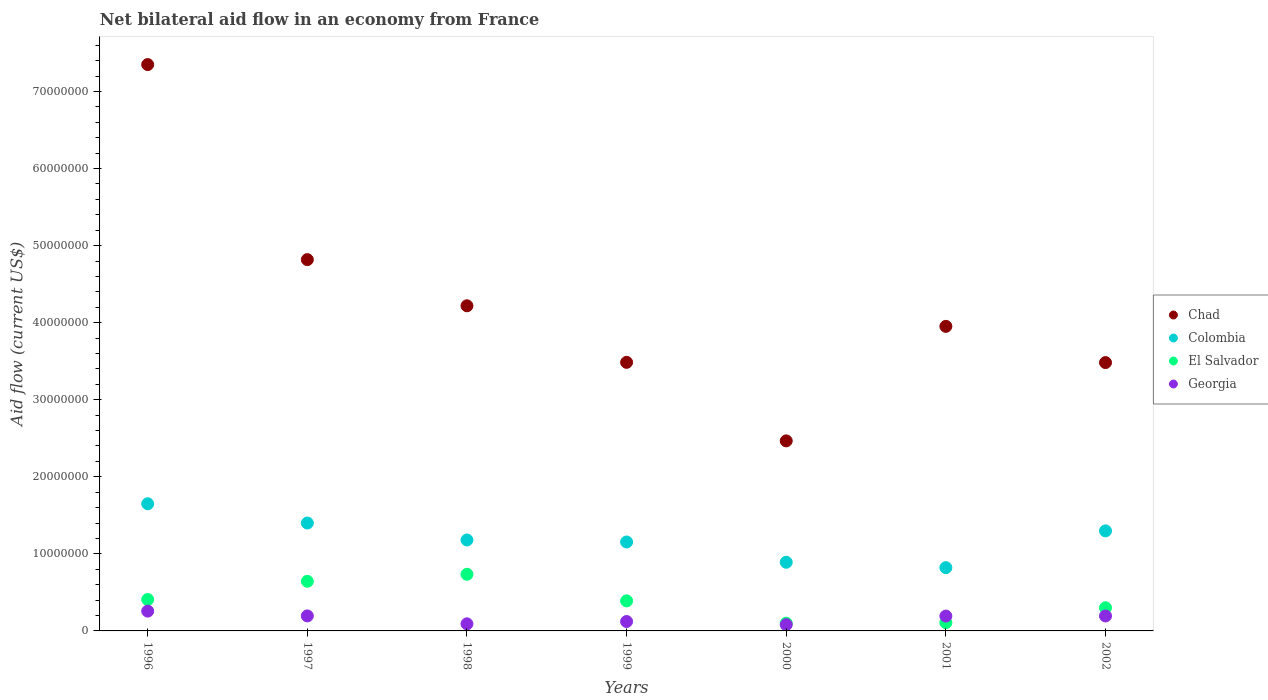How many different coloured dotlines are there?
Your answer should be compact. 4. What is the net bilateral aid flow in El Salvador in 1997?
Provide a succinct answer. 6.44e+06. Across all years, what is the maximum net bilateral aid flow in Georgia?
Your response must be concise. 2.57e+06. Across all years, what is the minimum net bilateral aid flow in El Salvador?
Your answer should be very brief. 1.00e+06. In which year was the net bilateral aid flow in El Salvador maximum?
Your answer should be very brief. 1998. What is the total net bilateral aid flow in El Salvador in the graph?
Offer a very short reply. 2.68e+07. What is the difference between the net bilateral aid flow in El Salvador in 1996 and that in 2002?
Give a very brief answer. 1.07e+06. What is the difference between the net bilateral aid flow in Chad in 1997 and the net bilateral aid flow in Colombia in 2001?
Provide a succinct answer. 4.00e+07. What is the average net bilateral aid flow in Colombia per year?
Provide a succinct answer. 1.20e+07. In the year 2001, what is the difference between the net bilateral aid flow in Chad and net bilateral aid flow in Georgia?
Your answer should be very brief. 3.76e+07. What is the ratio of the net bilateral aid flow in Colombia in 1999 to that in 2000?
Make the answer very short. 1.3. Is the net bilateral aid flow in Chad in 1997 less than that in 2001?
Ensure brevity in your answer.  No. What is the difference between the highest and the second highest net bilateral aid flow in Chad?
Ensure brevity in your answer.  2.53e+07. What is the difference between the highest and the lowest net bilateral aid flow in Colombia?
Offer a very short reply. 8.29e+06. Is the sum of the net bilateral aid flow in El Salvador in 1998 and 1999 greater than the maximum net bilateral aid flow in Chad across all years?
Ensure brevity in your answer.  No. Is it the case that in every year, the sum of the net bilateral aid flow in Chad and net bilateral aid flow in El Salvador  is greater than the sum of net bilateral aid flow in Colombia and net bilateral aid flow in Georgia?
Make the answer very short. Yes. Does the net bilateral aid flow in Georgia monotonically increase over the years?
Keep it short and to the point. No. Is the net bilateral aid flow in Georgia strictly less than the net bilateral aid flow in Chad over the years?
Offer a very short reply. Yes. How many years are there in the graph?
Provide a short and direct response. 7. Does the graph contain any zero values?
Give a very brief answer. No. Does the graph contain grids?
Offer a terse response. No. Where does the legend appear in the graph?
Your response must be concise. Center right. What is the title of the graph?
Make the answer very short. Net bilateral aid flow in an economy from France. What is the label or title of the X-axis?
Make the answer very short. Years. What is the Aid flow (current US$) of Chad in 1996?
Provide a short and direct response. 7.35e+07. What is the Aid flow (current US$) of Colombia in 1996?
Your answer should be compact. 1.65e+07. What is the Aid flow (current US$) in El Salvador in 1996?
Keep it short and to the point. 4.08e+06. What is the Aid flow (current US$) in Georgia in 1996?
Your response must be concise. 2.57e+06. What is the Aid flow (current US$) in Chad in 1997?
Your response must be concise. 4.82e+07. What is the Aid flow (current US$) of Colombia in 1997?
Keep it short and to the point. 1.40e+07. What is the Aid flow (current US$) of El Salvador in 1997?
Give a very brief answer. 6.44e+06. What is the Aid flow (current US$) of Georgia in 1997?
Give a very brief answer. 1.95e+06. What is the Aid flow (current US$) of Chad in 1998?
Your answer should be compact. 4.22e+07. What is the Aid flow (current US$) in Colombia in 1998?
Provide a succinct answer. 1.18e+07. What is the Aid flow (current US$) of El Salvador in 1998?
Offer a very short reply. 7.35e+06. What is the Aid flow (current US$) in Georgia in 1998?
Offer a terse response. 9.20e+05. What is the Aid flow (current US$) in Chad in 1999?
Your response must be concise. 3.48e+07. What is the Aid flow (current US$) in Colombia in 1999?
Your response must be concise. 1.15e+07. What is the Aid flow (current US$) of El Salvador in 1999?
Your answer should be very brief. 3.90e+06. What is the Aid flow (current US$) in Georgia in 1999?
Ensure brevity in your answer.  1.22e+06. What is the Aid flow (current US$) of Chad in 2000?
Make the answer very short. 2.47e+07. What is the Aid flow (current US$) in Colombia in 2000?
Offer a terse response. 8.91e+06. What is the Aid flow (current US$) in Georgia in 2000?
Your answer should be very brief. 8.10e+05. What is the Aid flow (current US$) in Chad in 2001?
Your response must be concise. 3.95e+07. What is the Aid flow (current US$) of Colombia in 2001?
Provide a succinct answer. 8.21e+06. What is the Aid flow (current US$) in El Salvador in 2001?
Provide a succinct answer. 1.07e+06. What is the Aid flow (current US$) in Georgia in 2001?
Provide a short and direct response. 1.93e+06. What is the Aid flow (current US$) in Chad in 2002?
Your answer should be very brief. 3.48e+07. What is the Aid flow (current US$) in Colombia in 2002?
Provide a succinct answer. 1.30e+07. What is the Aid flow (current US$) of El Salvador in 2002?
Your answer should be compact. 3.01e+06. What is the Aid flow (current US$) in Georgia in 2002?
Give a very brief answer. 1.94e+06. Across all years, what is the maximum Aid flow (current US$) in Chad?
Your response must be concise. 7.35e+07. Across all years, what is the maximum Aid flow (current US$) of Colombia?
Make the answer very short. 1.65e+07. Across all years, what is the maximum Aid flow (current US$) in El Salvador?
Ensure brevity in your answer.  7.35e+06. Across all years, what is the maximum Aid flow (current US$) of Georgia?
Make the answer very short. 2.57e+06. Across all years, what is the minimum Aid flow (current US$) of Chad?
Ensure brevity in your answer.  2.47e+07. Across all years, what is the minimum Aid flow (current US$) in Colombia?
Your answer should be very brief. 8.21e+06. Across all years, what is the minimum Aid flow (current US$) in El Salvador?
Your answer should be very brief. 1.00e+06. Across all years, what is the minimum Aid flow (current US$) in Georgia?
Make the answer very short. 8.10e+05. What is the total Aid flow (current US$) in Chad in the graph?
Your response must be concise. 2.98e+08. What is the total Aid flow (current US$) in Colombia in the graph?
Provide a succinct answer. 8.39e+07. What is the total Aid flow (current US$) of El Salvador in the graph?
Keep it short and to the point. 2.68e+07. What is the total Aid flow (current US$) of Georgia in the graph?
Make the answer very short. 1.13e+07. What is the difference between the Aid flow (current US$) in Chad in 1996 and that in 1997?
Make the answer very short. 2.53e+07. What is the difference between the Aid flow (current US$) in Colombia in 1996 and that in 1997?
Give a very brief answer. 2.50e+06. What is the difference between the Aid flow (current US$) in El Salvador in 1996 and that in 1997?
Your answer should be very brief. -2.36e+06. What is the difference between the Aid flow (current US$) in Georgia in 1996 and that in 1997?
Ensure brevity in your answer.  6.20e+05. What is the difference between the Aid flow (current US$) in Chad in 1996 and that in 1998?
Provide a succinct answer. 3.13e+07. What is the difference between the Aid flow (current US$) in Colombia in 1996 and that in 1998?
Offer a terse response. 4.70e+06. What is the difference between the Aid flow (current US$) of El Salvador in 1996 and that in 1998?
Your answer should be very brief. -3.27e+06. What is the difference between the Aid flow (current US$) of Georgia in 1996 and that in 1998?
Your answer should be compact. 1.65e+06. What is the difference between the Aid flow (current US$) of Chad in 1996 and that in 1999?
Make the answer very short. 3.86e+07. What is the difference between the Aid flow (current US$) of Colombia in 1996 and that in 1999?
Ensure brevity in your answer.  4.96e+06. What is the difference between the Aid flow (current US$) of El Salvador in 1996 and that in 1999?
Ensure brevity in your answer.  1.80e+05. What is the difference between the Aid flow (current US$) of Georgia in 1996 and that in 1999?
Your answer should be very brief. 1.35e+06. What is the difference between the Aid flow (current US$) in Chad in 1996 and that in 2000?
Make the answer very short. 4.88e+07. What is the difference between the Aid flow (current US$) in Colombia in 1996 and that in 2000?
Provide a succinct answer. 7.59e+06. What is the difference between the Aid flow (current US$) in El Salvador in 1996 and that in 2000?
Offer a very short reply. 3.08e+06. What is the difference between the Aid flow (current US$) in Georgia in 1996 and that in 2000?
Keep it short and to the point. 1.76e+06. What is the difference between the Aid flow (current US$) in Chad in 1996 and that in 2001?
Your answer should be compact. 3.40e+07. What is the difference between the Aid flow (current US$) of Colombia in 1996 and that in 2001?
Make the answer very short. 8.29e+06. What is the difference between the Aid flow (current US$) of El Salvador in 1996 and that in 2001?
Provide a short and direct response. 3.01e+06. What is the difference between the Aid flow (current US$) in Georgia in 1996 and that in 2001?
Give a very brief answer. 6.40e+05. What is the difference between the Aid flow (current US$) in Chad in 1996 and that in 2002?
Offer a very short reply. 3.87e+07. What is the difference between the Aid flow (current US$) in Colombia in 1996 and that in 2002?
Your answer should be compact. 3.52e+06. What is the difference between the Aid flow (current US$) of El Salvador in 1996 and that in 2002?
Your response must be concise. 1.07e+06. What is the difference between the Aid flow (current US$) in Georgia in 1996 and that in 2002?
Offer a terse response. 6.30e+05. What is the difference between the Aid flow (current US$) of Chad in 1997 and that in 1998?
Keep it short and to the point. 5.99e+06. What is the difference between the Aid flow (current US$) in Colombia in 1997 and that in 1998?
Give a very brief answer. 2.20e+06. What is the difference between the Aid flow (current US$) in El Salvador in 1997 and that in 1998?
Give a very brief answer. -9.10e+05. What is the difference between the Aid flow (current US$) of Georgia in 1997 and that in 1998?
Offer a terse response. 1.03e+06. What is the difference between the Aid flow (current US$) in Chad in 1997 and that in 1999?
Keep it short and to the point. 1.33e+07. What is the difference between the Aid flow (current US$) of Colombia in 1997 and that in 1999?
Ensure brevity in your answer.  2.46e+06. What is the difference between the Aid flow (current US$) of El Salvador in 1997 and that in 1999?
Your response must be concise. 2.54e+06. What is the difference between the Aid flow (current US$) of Georgia in 1997 and that in 1999?
Ensure brevity in your answer.  7.30e+05. What is the difference between the Aid flow (current US$) in Chad in 1997 and that in 2000?
Your answer should be compact. 2.35e+07. What is the difference between the Aid flow (current US$) in Colombia in 1997 and that in 2000?
Keep it short and to the point. 5.09e+06. What is the difference between the Aid flow (current US$) in El Salvador in 1997 and that in 2000?
Give a very brief answer. 5.44e+06. What is the difference between the Aid flow (current US$) in Georgia in 1997 and that in 2000?
Your response must be concise. 1.14e+06. What is the difference between the Aid flow (current US$) in Chad in 1997 and that in 2001?
Provide a succinct answer. 8.66e+06. What is the difference between the Aid flow (current US$) of Colombia in 1997 and that in 2001?
Give a very brief answer. 5.79e+06. What is the difference between the Aid flow (current US$) in El Salvador in 1997 and that in 2001?
Ensure brevity in your answer.  5.37e+06. What is the difference between the Aid flow (current US$) of Chad in 1997 and that in 2002?
Keep it short and to the point. 1.34e+07. What is the difference between the Aid flow (current US$) in Colombia in 1997 and that in 2002?
Keep it short and to the point. 1.02e+06. What is the difference between the Aid flow (current US$) of El Salvador in 1997 and that in 2002?
Offer a very short reply. 3.43e+06. What is the difference between the Aid flow (current US$) in Georgia in 1997 and that in 2002?
Give a very brief answer. 10000. What is the difference between the Aid flow (current US$) of Chad in 1998 and that in 1999?
Your answer should be very brief. 7.34e+06. What is the difference between the Aid flow (current US$) of Colombia in 1998 and that in 1999?
Your answer should be compact. 2.60e+05. What is the difference between the Aid flow (current US$) in El Salvador in 1998 and that in 1999?
Your answer should be compact. 3.45e+06. What is the difference between the Aid flow (current US$) in Georgia in 1998 and that in 1999?
Make the answer very short. -3.00e+05. What is the difference between the Aid flow (current US$) in Chad in 1998 and that in 2000?
Your answer should be compact. 1.75e+07. What is the difference between the Aid flow (current US$) in Colombia in 1998 and that in 2000?
Give a very brief answer. 2.89e+06. What is the difference between the Aid flow (current US$) of El Salvador in 1998 and that in 2000?
Make the answer very short. 6.35e+06. What is the difference between the Aid flow (current US$) in Georgia in 1998 and that in 2000?
Give a very brief answer. 1.10e+05. What is the difference between the Aid flow (current US$) in Chad in 1998 and that in 2001?
Provide a succinct answer. 2.67e+06. What is the difference between the Aid flow (current US$) in Colombia in 1998 and that in 2001?
Your answer should be compact. 3.59e+06. What is the difference between the Aid flow (current US$) of El Salvador in 1998 and that in 2001?
Ensure brevity in your answer.  6.28e+06. What is the difference between the Aid flow (current US$) of Georgia in 1998 and that in 2001?
Offer a very short reply. -1.01e+06. What is the difference between the Aid flow (current US$) in Chad in 1998 and that in 2002?
Your response must be concise. 7.37e+06. What is the difference between the Aid flow (current US$) of Colombia in 1998 and that in 2002?
Give a very brief answer. -1.18e+06. What is the difference between the Aid flow (current US$) of El Salvador in 1998 and that in 2002?
Provide a succinct answer. 4.34e+06. What is the difference between the Aid flow (current US$) of Georgia in 1998 and that in 2002?
Keep it short and to the point. -1.02e+06. What is the difference between the Aid flow (current US$) of Chad in 1999 and that in 2000?
Your answer should be very brief. 1.02e+07. What is the difference between the Aid flow (current US$) of Colombia in 1999 and that in 2000?
Give a very brief answer. 2.63e+06. What is the difference between the Aid flow (current US$) of El Salvador in 1999 and that in 2000?
Offer a very short reply. 2.90e+06. What is the difference between the Aid flow (current US$) of Chad in 1999 and that in 2001?
Provide a succinct answer. -4.67e+06. What is the difference between the Aid flow (current US$) in Colombia in 1999 and that in 2001?
Give a very brief answer. 3.33e+06. What is the difference between the Aid flow (current US$) of El Salvador in 1999 and that in 2001?
Ensure brevity in your answer.  2.83e+06. What is the difference between the Aid flow (current US$) of Georgia in 1999 and that in 2001?
Keep it short and to the point. -7.10e+05. What is the difference between the Aid flow (current US$) in Colombia in 1999 and that in 2002?
Offer a terse response. -1.44e+06. What is the difference between the Aid flow (current US$) in El Salvador in 1999 and that in 2002?
Ensure brevity in your answer.  8.90e+05. What is the difference between the Aid flow (current US$) in Georgia in 1999 and that in 2002?
Your answer should be compact. -7.20e+05. What is the difference between the Aid flow (current US$) of Chad in 2000 and that in 2001?
Ensure brevity in your answer.  -1.49e+07. What is the difference between the Aid flow (current US$) of El Salvador in 2000 and that in 2001?
Your response must be concise. -7.00e+04. What is the difference between the Aid flow (current US$) of Georgia in 2000 and that in 2001?
Provide a succinct answer. -1.12e+06. What is the difference between the Aid flow (current US$) of Chad in 2000 and that in 2002?
Give a very brief answer. -1.02e+07. What is the difference between the Aid flow (current US$) of Colombia in 2000 and that in 2002?
Offer a very short reply. -4.07e+06. What is the difference between the Aid flow (current US$) in El Salvador in 2000 and that in 2002?
Keep it short and to the point. -2.01e+06. What is the difference between the Aid flow (current US$) in Georgia in 2000 and that in 2002?
Give a very brief answer. -1.13e+06. What is the difference between the Aid flow (current US$) of Chad in 2001 and that in 2002?
Offer a terse response. 4.70e+06. What is the difference between the Aid flow (current US$) of Colombia in 2001 and that in 2002?
Your answer should be very brief. -4.77e+06. What is the difference between the Aid flow (current US$) of El Salvador in 2001 and that in 2002?
Your answer should be compact. -1.94e+06. What is the difference between the Aid flow (current US$) of Chad in 1996 and the Aid flow (current US$) of Colombia in 1997?
Provide a short and direct response. 5.95e+07. What is the difference between the Aid flow (current US$) of Chad in 1996 and the Aid flow (current US$) of El Salvador in 1997?
Offer a very short reply. 6.70e+07. What is the difference between the Aid flow (current US$) of Chad in 1996 and the Aid flow (current US$) of Georgia in 1997?
Give a very brief answer. 7.15e+07. What is the difference between the Aid flow (current US$) in Colombia in 1996 and the Aid flow (current US$) in El Salvador in 1997?
Provide a short and direct response. 1.01e+07. What is the difference between the Aid flow (current US$) in Colombia in 1996 and the Aid flow (current US$) in Georgia in 1997?
Offer a very short reply. 1.46e+07. What is the difference between the Aid flow (current US$) in El Salvador in 1996 and the Aid flow (current US$) in Georgia in 1997?
Your response must be concise. 2.13e+06. What is the difference between the Aid flow (current US$) of Chad in 1996 and the Aid flow (current US$) of Colombia in 1998?
Your answer should be compact. 6.17e+07. What is the difference between the Aid flow (current US$) in Chad in 1996 and the Aid flow (current US$) in El Salvador in 1998?
Your response must be concise. 6.61e+07. What is the difference between the Aid flow (current US$) in Chad in 1996 and the Aid flow (current US$) in Georgia in 1998?
Offer a very short reply. 7.26e+07. What is the difference between the Aid flow (current US$) of Colombia in 1996 and the Aid flow (current US$) of El Salvador in 1998?
Keep it short and to the point. 9.15e+06. What is the difference between the Aid flow (current US$) in Colombia in 1996 and the Aid flow (current US$) in Georgia in 1998?
Ensure brevity in your answer.  1.56e+07. What is the difference between the Aid flow (current US$) of El Salvador in 1996 and the Aid flow (current US$) of Georgia in 1998?
Offer a terse response. 3.16e+06. What is the difference between the Aid flow (current US$) of Chad in 1996 and the Aid flow (current US$) of Colombia in 1999?
Ensure brevity in your answer.  6.20e+07. What is the difference between the Aid flow (current US$) in Chad in 1996 and the Aid flow (current US$) in El Salvador in 1999?
Offer a very short reply. 6.96e+07. What is the difference between the Aid flow (current US$) in Chad in 1996 and the Aid flow (current US$) in Georgia in 1999?
Your answer should be compact. 7.23e+07. What is the difference between the Aid flow (current US$) in Colombia in 1996 and the Aid flow (current US$) in El Salvador in 1999?
Give a very brief answer. 1.26e+07. What is the difference between the Aid flow (current US$) of Colombia in 1996 and the Aid flow (current US$) of Georgia in 1999?
Give a very brief answer. 1.53e+07. What is the difference between the Aid flow (current US$) of El Salvador in 1996 and the Aid flow (current US$) of Georgia in 1999?
Your answer should be very brief. 2.86e+06. What is the difference between the Aid flow (current US$) of Chad in 1996 and the Aid flow (current US$) of Colombia in 2000?
Your response must be concise. 6.46e+07. What is the difference between the Aid flow (current US$) in Chad in 1996 and the Aid flow (current US$) in El Salvador in 2000?
Ensure brevity in your answer.  7.25e+07. What is the difference between the Aid flow (current US$) in Chad in 1996 and the Aid flow (current US$) in Georgia in 2000?
Your response must be concise. 7.27e+07. What is the difference between the Aid flow (current US$) of Colombia in 1996 and the Aid flow (current US$) of El Salvador in 2000?
Your answer should be very brief. 1.55e+07. What is the difference between the Aid flow (current US$) of Colombia in 1996 and the Aid flow (current US$) of Georgia in 2000?
Keep it short and to the point. 1.57e+07. What is the difference between the Aid flow (current US$) in El Salvador in 1996 and the Aid flow (current US$) in Georgia in 2000?
Your response must be concise. 3.27e+06. What is the difference between the Aid flow (current US$) of Chad in 1996 and the Aid flow (current US$) of Colombia in 2001?
Your answer should be very brief. 6.53e+07. What is the difference between the Aid flow (current US$) in Chad in 1996 and the Aid flow (current US$) in El Salvador in 2001?
Make the answer very short. 7.24e+07. What is the difference between the Aid flow (current US$) of Chad in 1996 and the Aid flow (current US$) of Georgia in 2001?
Keep it short and to the point. 7.16e+07. What is the difference between the Aid flow (current US$) of Colombia in 1996 and the Aid flow (current US$) of El Salvador in 2001?
Your response must be concise. 1.54e+07. What is the difference between the Aid flow (current US$) of Colombia in 1996 and the Aid flow (current US$) of Georgia in 2001?
Your response must be concise. 1.46e+07. What is the difference between the Aid flow (current US$) of El Salvador in 1996 and the Aid flow (current US$) of Georgia in 2001?
Keep it short and to the point. 2.15e+06. What is the difference between the Aid flow (current US$) in Chad in 1996 and the Aid flow (current US$) in Colombia in 2002?
Your answer should be compact. 6.05e+07. What is the difference between the Aid flow (current US$) in Chad in 1996 and the Aid flow (current US$) in El Salvador in 2002?
Give a very brief answer. 7.05e+07. What is the difference between the Aid flow (current US$) of Chad in 1996 and the Aid flow (current US$) of Georgia in 2002?
Give a very brief answer. 7.16e+07. What is the difference between the Aid flow (current US$) in Colombia in 1996 and the Aid flow (current US$) in El Salvador in 2002?
Keep it short and to the point. 1.35e+07. What is the difference between the Aid flow (current US$) of Colombia in 1996 and the Aid flow (current US$) of Georgia in 2002?
Your answer should be very brief. 1.46e+07. What is the difference between the Aid flow (current US$) in El Salvador in 1996 and the Aid flow (current US$) in Georgia in 2002?
Provide a succinct answer. 2.14e+06. What is the difference between the Aid flow (current US$) of Chad in 1997 and the Aid flow (current US$) of Colombia in 1998?
Your response must be concise. 3.64e+07. What is the difference between the Aid flow (current US$) in Chad in 1997 and the Aid flow (current US$) in El Salvador in 1998?
Your response must be concise. 4.08e+07. What is the difference between the Aid flow (current US$) in Chad in 1997 and the Aid flow (current US$) in Georgia in 1998?
Your answer should be very brief. 4.73e+07. What is the difference between the Aid flow (current US$) of Colombia in 1997 and the Aid flow (current US$) of El Salvador in 1998?
Your response must be concise. 6.65e+06. What is the difference between the Aid flow (current US$) in Colombia in 1997 and the Aid flow (current US$) in Georgia in 1998?
Your response must be concise. 1.31e+07. What is the difference between the Aid flow (current US$) in El Salvador in 1997 and the Aid flow (current US$) in Georgia in 1998?
Your answer should be compact. 5.52e+06. What is the difference between the Aid flow (current US$) of Chad in 1997 and the Aid flow (current US$) of Colombia in 1999?
Give a very brief answer. 3.66e+07. What is the difference between the Aid flow (current US$) in Chad in 1997 and the Aid flow (current US$) in El Salvador in 1999?
Provide a succinct answer. 4.43e+07. What is the difference between the Aid flow (current US$) in Chad in 1997 and the Aid flow (current US$) in Georgia in 1999?
Provide a short and direct response. 4.70e+07. What is the difference between the Aid flow (current US$) in Colombia in 1997 and the Aid flow (current US$) in El Salvador in 1999?
Provide a succinct answer. 1.01e+07. What is the difference between the Aid flow (current US$) in Colombia in 1997 and the Aid flow (current US$) in Georgia in 1999?
Provide a short and direct response. 1.28e+07. What is the difference between the Aid flow (current US$) in El Salvador in 1997 and the Aid flow (current US$) in Georgia in 1999?
Ensure brevity in your answer.  5.22e+06. What is the difference between the Aid flow (current US$) of Chad in 1997 and the Aid flow (current US$) of Colombia in 2000?
Offer a terse response. 3.93e+07. What is the difference between the Aid flow (current US$) in Chad in 1997 and the Aid flow (current US$) in El Salvador in 2000?
Your response must be concise. 4.72e+07. What is the difference between the Aid flow (current US$) in Chad in 1997 and the Aid flow (current US$) in Georgia in 2000?
Your answer should be compact. 4.74e+07. What is the difference between the Aid flow (current US$) of Colombia in 1997 and the Aid flow (current US$) of El Salvador in 2000?
Keep it short and to the point. 1.30e+07. What is the difference between the Aid flow (current US$) in Colombia in 1997 and the Aid flow (current US$) in Georgia in 2000?
Offer a terse response. 1.32e+07. What is the difference between the Aid flow (current US$) of El Salvador in 1997 and the Aid flow (current US$) of Georgia in 2000?
Give a very brief answer. 5.63e+06. What is the difference between the Aid flow (current US$) of Chad in 1997 and the Aid flow (current US$) of Colombia in 2001?
Your answer should be very brief. 4.00e+07. What is the difference between the Aid flow (current US$) in Chad in 1997 and the Aid flow (current US$) in El Salvador in 2001?
Offer a very short reply. 4.71e+07. What is the difference between the Aid flow (current US$) of Chad in 1997 and the Aid flow (current US$) of Georgia in 2001?
Offer a terse response. 4.62e+07. What is the difference between the Aid flow (current US$) in Colombia in 1997 and the Aid flow (current US$) in El Salvador in 2001?
Your response must be concise. 1.29e+07. What is the difference between the Aid flow (current US$) of Colombia in 1997 and the Aid flow (current US$) of Georgia in 2001?
Provide a short and direct response. 1.21e+07. What is the difference between the Aid flow (current US$) of El Salvador in 1997 and the Aid flow (current US$) of Georgia in 2001?
Ensure brevity in your answer.  4.51e+06. What is the difference between the Aid flow (current US$) of Chad in 1997 and the Aid flow (current US$) of Colombia in 2002?
Offer a terse response. 3.52e+07. What is the difference between the Aid flow (current US$) in Chad in 1997 and the Aid flow (current US$) in El Salvador in 2002?
Make the answer very short. 4.52e+07. What is the difference between the Aid flow (current US$) in Chad in 1997 and the Aid flow (current US$) in Georgia in 2002?
Keep it short and to the point. 4.62e+07. What is the difference between the Aid flow (current US$) of Colombia in 1997 and the Aid flow (current US$) of El Salvador in 2002?
Your answer should be very brief. 1.10e+07. What is the difference between the Aid flow (current US$) in Colombia in 1997 and the Aid flow (current US$) in Georgia in 2002?
Offer a very short reply. 1.21e+07. What is the difference between the Aid flow (current US$) of El Salvador in 1997 and the Aid flow (current US$) of Georgia in 2002?
Ensure brevity in your answer.  4.50e+06. What is the difference between the Aid flow (current US$) in Chad in 1998 and the Aid flow (current US$) in Colombia in 1999?
Keep it short and to the point. 3.06e+07. What is the difference between the Aid flow (current US$) in Chad in 1998 and the Aid flow (current US$) in El Salvador in 1999?
Your response must be concise. 3.83e+07. What is the difference between the Aid flow (current US$) of Chad in 1998 and the Aid flow (current US$) of Georgia in 1999?
Make the answer very short. 4.10e+07. What is the difference between the Aid flow (current US$) in Colombia in 1998 and the Aid flow (current US$) in El Salvador in 1999?
Keep it short and to the point. 7.90e+06. What is the difference between the Aid flow (current US$) of Colombia in 1998 and the Aid flow (current US$) of Georgia in 1999?
Offer a terse response. 1.06e+07. What is the difference between the Aid flow (current US$) of El Salvador in 1998 and the Aid flow (current US$) of Georgia in 1999?
Keep it short and to the point. 6.13e+06. What is the difference between the Aid flow (current US$) in Chad in 1998 and the Aid flow (current US$) in Colombia in 2000?
Offer a terse response. 3.33e+07. What is the difference between the Aid flow (current US$) in Chad in 1998 and the Aid flow (current US$) in El Salvador in 2000?
Keep it short and to the point. 4.12e+07. What is the difference between the Aid flow (current US$) in Chad in 1998 and the Aid flow (current US$) in Georgia in 2000?
Offer a very short reply. 4.14e+07. What is the difference between the Aid flow (current US$) of Colombia in 1998 and the Aid flow (current US$) of El Salvador in 2000?
Provide a short and direct response. 1.08e+07. What is the difference between the Aid flow (current US$) in Colombia in 1998 and the Aid flow (current US$) in Georgia in 2000?
Keep it short and to the point. 1.10e+07. What is the difference between the Aid flow (current US$) in El Salvador in 1998 and the Aid flow (current US$) in Georgia in 2000?
Make the answer very short. 6.54e+06. What is the difference between the Aid flow (current US$) of Chad in 1998 and the Aid flow (current US$) of Colombia in 2001?
Provide a succinct answer. 3.40e+07. What is the difference between the Aid flow (current US$) in Chad in 1998 and the Aid flow (current US$) in El Salvador in 2001?
Ensure brevity in your answer.  4.11e+07. What is the difference between the Aid flow (current US$) of Chad in 1998 and the Aid flow (current US$) of Georgia in 2001?
Your answer should be compact. 4.03e+07. What is the difference between the Aid flow (current US$) in Colombia in 1998 and the Aid flow (current US$) in El Salvador in 2001?
Your answer should be compact. 1.07e+07. What is the difference between the Aid flow (current US$) of Colombia in 1998 and the Aid flow (current US$) of Georgia in 2001?
Offer a terse response. 9.87e+06. What is the difference between the Aid flow (current US$) of El Salvador in 1998 and the Aid flow (current US$) of Georgia in 2001?
Provide a short and direct response. 5.42e+06. What is the difference between the Aid flow (current US$) of Chad in 1998 and the Aid flow (current US$) of Colombia in 2002?
Offer a terse response. 2.92e+07. What is the difference between the Aid flow (current US$) of Chad in 1998 and the Aid flow (current US$) of El Salvador in 2002?
Make the answer very short. 3.92e+07. What is the difference between the Aid flow (current US$) of Chad in 1998 and the Aid flow (current US$) of Georgia in 2002?
Your answer should be compact. 4.02e+07. What is the difference between the Aid flow (current US$) in Colombia in 1998 and the Aid flow (current US$) in El Salvador in 2002?
Make the answer very short. 8.79e+06. What is the difference between the Aid flow (current US$) of Colombia in 1998 and the Aid flow (current US$) of Georgia in 2002?
Offer a terse response. 9.86e+06. What is the difference between the Aid flow (current US$) in El Salvador in 1998 and the Aid flow (current US$) in Georgia in 2002?
Keep it short and to the point. 5.41e+06. What is the difference between the Aid flow (current US$) in Chad in 1999 and the Aid flow (current US$) in Colombia in 2000?
Your response must be concise. 2.59e+07. What is the difference between the Aid flow (current US$) in Chad in 1999 and the Aid flow (current US$) in El Salvador in 2000?
Provide a succinct answer. 3.38e+07. What is the difference between the Aid flow (current US$) of Chad in 1999 and the Aid flow (current US$) of Georgia in 2000?
Provide a succinct answer. 3.40e+07. What is the difference between the Aid flow (current US$) in Colombia in 1999 and the Aid flow (current US$) in El Salvador in 2000?
Provide a succinct answer. 1.05e+07. What is the difference between the Aid flow (current US$) in Colombia in 1999 and the Aid flow (current US$) in Georgia in 2000?
Offer a very short reply. 1.07e+07. What is the difference between the Aid flow (current US$) of El Salvador in 1999 and the Aid flow (current US$) of Georgia in 2000?
Your answer should be very brief. 3.09e+06. What is the difference between the Aid flow (current US$) in Chad in 1999 and the Aid flow (current US$) in Colombia in 2001?
Keep it short and to the point. 2.66e+07. What is the difference between the Aid flow (current US$) in Chad in 1999 and the Aid flow (current US$) in El Salvador in 2001?
Give a very brief answer. 3.38e+07. What is the difference between the Aid flow (current US$) in Chad in 1999 and the Aid flow (current US$) in Georgia in 2001?
Offer a very short reply. 3.29e+07. What is the difference between the Aid flow (current US$) in Colombia in 1999 and the Aid flow (current US$) in El Salvador in 2001?
Your answer should be very brief. 1.05e+07. What is the difference between the Aid flow (current US$) of Colombia in 1999 and the Aid flow (current US$) of Georgia in 2001?
Give a very brief answer. 9.61e+06. What is the difference between the Aid flow (current US$) of El Salvador in 1999 and the Aid flow (current US$) of Georgia in 2001?
Make the answer very short. 1.97e+06. What is the difference between the Aid flow (current US$) in Chad in 1999 and the Aid flow (current US$) in Colombia in 2002?
Make the answer very short. 2.19e+07. What is the difference between the Aid flow (current US$) in Chad in 1999 and the Aid flow (current US$) in El Salvador in 2002?
Your response must be concise. 3.18e+07. What is the difference between the Aid flow (current US$) of Chad in 1999 and the Aid flow (current US$) of Georgia in 2002?
Make the answer very short. 3.29e+07. What is the difference between the Aid flow (current US$) of Colombia in 1999 and the Aid flow (current US$) of El Salvador in 2002?
Ensure brevity in your answer.  8.53e+06. What is the difference between the Aid flow (current US$) of Colombia in 1999 and the Aid flow (current US$) of Georgia in 2002?
Give a very brief answer. 9.60e+06. What is the difference between the Aid flow (current US$) in El Salvador in 1999 and the Aid flow (current US$) in Georgia in 2002?
Offer a terse response. 1.96e+06. What is the difference between the Aid flow (current US$) in Chad in 2000 and the Aid flow (current US$) in Colombia in 2001?
Your answer should be compact. 1.64e+07. What is the difference between the Aid flow (current US$) of Chad in 2000 and the Aid flow (current US$) of El Salvador in 2001?
Your answer should be very brief. 2.36e+07. What is the difference between the Aid flow (current US$) in Chad in 2000 and the Aid flow (current US$) in Georgia in 2001?
Ensure brevity in your answer.  2.27e+07. What is the difference between the Aid flow (current US$) in Colombia in 2000 and the Aid flow (current US$) in El Salvador in 2001?
Your answer should be compact. 7.84e+06. What is the difference between the Aid flow (current US$) of Colombia in 2000 and the Aid flow (current US$) of Georgia in 2001?
Offer a very short reply. 6.98e+06. What is the difference between the Aid flow (current US$) in El Salvador in 2000 and the Aid flow (current US$) in Georgia in 2001?
Give a very brief answer. -9.30e+05. What is the difference between the Aid flow (current US$) in Chad in 2000 and the Aid flow (current US$) in Colombia in 2002?
Your answer should be very brief. 1.17e+07. What is the difference between the Aid flow (current US$) in Chad in 2000 and the Aid flow (current US$) in El Salvador in 2002?
Make the answer very short. 2.16e+07. What is the difference between the Aid flow (current US$) of Chad in 2000 and the Aid flow (current US$) of Georgia in 2002?
Offer a terse response. 2.27e+07. What is the difference between the Aid flow (current US$) of Colombia in 2000 and the Aid flow (current US$) of El Salvador in 2002?
Provide a succinct answer. 5.90e+06. What is the difference between the Aid flow (current US$) of Colombia in 2000 and the Aid flow (current US$) of Georgia in 2002?
Keep it short and to the point. 6.97e+06. What is the difference between the Aid flow (current US$) in El Salvador in 2000 and the Aid flow (current US$) in Georgia in 2002?
Your answer should be compact. -9.40e+05. What is the difference between the Aid flow (current US$) in Chad in 2001 and the Aid flow (current US$) in Colombia in 2002?
Your answer should be very brief. 2.65e+07. What is the difference between the Aid flow (current US$) of Chad in 2001 and the Aid flow (current US$) of El Salvador in 2002?
Provide a succinct answer. 3.65e+07. What is the difference between the Aid flow (current US$) of Chad in 2001 and the Aid flow (current US$) of Georgia in 2002?
Your answer should be very brief. 3.76e+07. What is the difference between the Aid flow (current US$) in Colombia in 2001 and the Aid flow (current US$) in El Salvador in 2002?
Keep it short and to the point. 5.20e+06. What is the difference between the Aid flow (current US$) of Colombia in 2001 and the Aid flow (current US$) of Georgia in 2002?
Ensure brevity in your answer.  6.27e+06. What is the difference between the Aid flow (current US$) of El Salvador in 2001 and the Aid flow (current US$) of Georgia in 2002?
Ensure brevity in your answer.  -8.70e+05. What is the average Aid flow (current US$) of Chad per year?
Keep it short and to the point. 4.25e+07. What is the average Aid flow (current US$) of Colombia per year?
Give a very brief answer. 1.20e+07. What is the average Aid flow (current US$) in El Salvador per year?
Keep it short and to the point. 3.84e+06. What is the average Aid flow (current US$) of Georgia per year?
Give a very brief answer. 1.62e+06. In the year 1996, what is the difference between the Aid flow (current US$) of Chad and Aid flow (current US$) of Colombia?
Ensure brevity in your answer.  5.70e+07. In the year 1996, what is the difference between the Aid flow (current US$) of Chad and Aid flow (current US$) of El Salvador?
Your response must be concise. 6.94e+07. In the year 1996, what is the difference between the Aid flow (current US$) in Chad and Aid flow (current US$) in Georgia?
Make the answer very short. 7.09e+07. In the year 1996, what is the difference between the Aid flow (current US$) in Colombia and Aid flow (current US$) in El Salvador?
Ensure brevity in your answer.  1.24e+07. In the year 1996, what is the difference between the Aid flow (current US$) in Colombia and Aid flow (current US$) in Georgia?
Make the answer very short. 1.39e+07. In the year 1996, what is the difference between the Aid flow (current US$) in El Salvador and Aid flow (current US$) in Georgia?
Ensure brevity in your answer.  1.51e+06. In the year 1997, what is the difference between the Aid flow (current US$) of Chad and Aid flow (current US$) of Colombia?
Provide a short and direct response. 3.42e+07. In the year 1997, what is the difference between the Aid flow (current US$) of Chad and Aid flow (current US$) of El Salvador?
Ensure brevity in your answer.  4.17e+07. In the year 1997, what is the difference between the Aid flow (current US$) of Chad and Aid flow (current US$) of Georgia?
Provide a short and direct response. 4.62e+07. In the year 1997, what is the difference between the Aid flow (current US$) in Colombia and Aid flow (current US$) in El Salvador?
Provide a succinct answer. 7.56e+06. In the year 1997, what is the difference between the Aid flow (current US$) of Colombia and Aid flow (current US$) of Georgia?
Keep it short and to the point. 1.20e+07. In the year 1997, what is the difference between the Aid flow (current US$) in El Salvador and Aid flow (current US$) in Georgia?
Ensure brevity in your answer.  4.49e+06. In the year 1998, what is the difference between the Aid flow (current US$) in Chad and Aid flow (current US$) in Colombia?
Offer a terse response. 3.04e+07. In the year 1998, what is the difference between the Aid flow (current US$) of Chad and Aid flow (current US$) of El Salvador?
Your answer should be compact. 3.48e+07. In the year 1998, what is the difference between the Aid flow (current US$) of Chad and Aid flow (current US$) of Georgia?
Ensure brevity in your answer.  4.13e+07. In the year 1998, what is the difference between the Aid flow (current US$) in Colombia and Aid flow (current US$) in El Salvador?
Your answer should be compact. 4.45e+06. In the year 1998, what is the difference between the Aid flow (current US$) in Colombia and Aid flow (current US$) in Georgia?
Give a very brief answer. 1.09e+07. In the year 1998, what is the difference between the Aid flow (current US$) of El Salvador and Aid flow (current US$) of Georgia?
Keep it short and to the point. 6.43e+06. In the year 1999, what is the difference between the Aid flow (current US$) of Chad and Aid flow (current US$) of Colombia?
Ensure brevity in your answer.  2.33e+07. In the year 1999, what is the difference between the Aid flow (current US$) of Chad and Aid flow (current US$) of El Salvador?
Ensure brevity in your answer.  3.10e+07. In the year 1999, what is the difference between the Aid flow (current US$) of Chad and Aid flow (current US$) of Georgia?
Give a very brief answer. 3.36e+07. In the year 1999, what is the difference between the Aid flow (current US$) of Colombia and Aid flow (current US$) of El Salvador?
Make the answer very short. 7.64e+06. In the year 1999, what is the difference between the Aid flow (current US$) of Colombia and Aid flow (current US$) of Georgia?
Provide a succinct answer. 1.03e+07. In the year 1999, what is the difference between the Aid flow (current US$) in El Salvador and Aid flow (current US$) in Georgia?
Your answer should be very brief. 2.68e+06. In the year 2000, what is the difference between the Aid flow (current US$) of Chad and Aid flow (current US$) of Colombia?
Give a very brief answer. 1.58e+07. In the year 2000, what is the difference between the Aid flow (current US$) in Chad and Aid flow (current US$) in El Salvador?
Your answer should be very brief. 2.37e+07. In the year 2000, what is the difference between the Aid flow (current US$) of Chad and Aid flow (current US$) of Georgia?
Ensure brevity in your answer.  2.38e+07. In the year 2000, what is the difference between the Aid flow (current US$) of Colombia and Aid flow (current US$) of El Salvador?
Make the answer very short. 7.91e+06. In the year 2000, what is the difference between the Aid flow (current US$) of Colombia and Aid flow (current US$) of Georgia?
Offer a terse response. 8.10e+06. In the year 2000, what is the difference between the Aid flow (current US$) of El Salvador and Aid flow (current US$) of Georgia?
Offer a very short reply. 1.90e+05. In the year 2001, what is the difference between the Aid flow (current US$) in Chad and Aid flow (current US$) in Colombia?
Give a very brief answer. 3.13e+07. In the year 2001, what is the difference between the Aid flow (current US$) in Chad and Aid flow (current US$) in El Salvador?
Provide a succinct answer. 3.84e+07. In the year 2001, what is the difference between the Aid flow (current US$) in Chad and Aid flow (current US$) in Georgia?
Offer a very short reply. 3.76e+07. In the year 2001, what is the difference between the Aid flow (current US$) of Colombia and Aid flow (current US$) of El Salvador?
Your answer should be compact. 7.14e+06. In the year 2001, what is the difference between the Aid flow (current US$) in Colombia and Aid flow (current US$) in Georgia?
Keep it short and to the point. 6.28e+06. In the year 2001, what is the difference between the Aid flow (current US$) of El Salvador and Aid flow (current US$) of Georgia?
Provide a succinct answer. -8.60e+05. In the year 2002, what is the difference between the Aid flow (current US$) of Chad and Aid flow (current US$) of Colombia?
Provide a succinct answer. 2.18e+07. In the year 2002, what is the difference between the Aid flow (current US$) of Chad and Aid flow (current US$) of El Salvador?
Provide a short and direct response. 3.18e+07. In the year 2002, what is the difference between the Aid flow (current US$) of Chad and Aid flow (current US$) of Georgia?
Your response must be concise. 3.29e+07. In the year 2002, what is the difference between the Aid flow (current US$) in Colombia and Aid flow (current US$) in El Salvador?
Provide a succinct answer. 9.97e+06. In the year 2002, what is the difference between the Aid flow (current US$) of Colombia and Aid flow (current US$) of Georgia?
Ensure brevity in your answer.  1.10e+07. In the year 2002, what is the difference between the Aid flow (current US$) in El Salvador and Aid flow (current US$) in Georgia?
Make the answer very short. 1.07e+06. What is the ratio of the Aid flow (current US$) of Chad in 1996 to that in 1997?
Provide a short and direct response. 1.53. What is the ratio of the Aid flow (current US$) of Colombia in 1996 to that in 1997?
Give a very brief answer. 1.18. What is the ratio of the Aid flow (current US$) in El Salvador in 1996 to that in 1997?
Your answer should be very brief. 0.63. What is the ratio of the Aid flow (current US$) in Georgia in 1996 to that in 1997?
Provide a short and direct response. 1.32. What is the ratio of the Aid flow (current US$) of Chad in 1996 to that in 1998?
Keep it short and to the point. 1.74. What is the ratio of the Aid flow (current US$) of Colombia in 1996 to that in 1998?
Offer a very short reply. 1.4. What is the ratio of the Aid flow (current US$) of El Salvador in 1996 to that in 1998?
Keep it short and to the point. 0.56. What is the ratio of the Aid flow (current US$) in Georgia in 1996 to that in 1998?
Provide a short and direct response. 2.79. What is the ratio of the Aid flow (current US$) in Chad in 1996 to that in 1999?
Offer a terse response. 2.11. What is the ratio of the Aid flow (current US$) of Colombia in 1996 to that in 1999?
Ensure brevity in your answer.  1.43. What is the ratio of the Aid flow (current US$) in El Salvador in 1996 to that in 1999?
Offer a very short reply. 1.05. What is the ratio of the Aid flow (current US$) in Georgia in 1996 to that in 1999?
Ensure brevity in your answer.  2.11. What is the ratio of the Aid flow (current US$) of Chad in 1996 to that in 2000?
Keep it short and to the point. 2.98. What is the ratio of the Aid flow (current US$) in Colombia in 1996 to that in 2000?
Ensure brevity in your answer.  1.85. What is the ratio of the Aid flow (current US$) of El Salvador in 1996 to that in 2000?
Offer a terse response. 4.08. What is the ratio of the Aid flow (current US$) in Georgia in 1996 to that in 2000?
Give a very brief answer. 3.17. What is the ratio of the Aid flow (current US$) in Chad in 1996 to that in 2001?
Your answer should be compact. 1.86. What is the ratio of the Aid flow (current US$) of Colombia in 1996 to that in 2001?
Provide a short and direct response. 2.01. What is the ratio of the Aid flow (current US$) in El Salvador in 1996 to that in 2001?
Your response must be concise. 3.81. What is the ratio of the Aid flow (current US$) of Georgia in 1996 to that in 2001?
Ensure brevity in your answer.  1.33. What is the ratio of the Aid flow (current US$) of Chad in 1996 to that in 2002?
Provide a succinct answer. 2.11. What is the ratio of the Aid flow (current US$) in Colombia in 1996 to that in 2002?
Provide a succinct answer. 1.27. What is the ratio of the Aid flow (current US$) of El Salvador in 1996 to that in 2002?
Offer a very short reply. 1.36. What is the ratio of the Aid flow (current US$) of Georgia in 1996 to that in 2002?
Give a very brief answer. 1.32. What is the ratio of the Aid flow (current US$) in Chad in 1997 to that in 1998?
Your answer should be very brief. 1.14. What is the ratio of the Aid flow (current US$) in Colombia in 1997 to that in 1998?
Provide a succinct answer. 1.19. What is the ratio of the Aid flow (current US$) of El Salvador in 1997 to that in 1998?
Ensure brevity in your answer.  0.88. What is the ratio of the Aid flow (current US$) in Georgia in 1997 to that in 1998?
Keep it short and to the point. 2.12. What is the ratio of the Aid flow (current US$) in Chad in 1997 to that in 1999?
Keep it short and to the point. 1.38. What is the ratio of the Aid flow (current US$) of Colombia in 1997 to that in 1999?
Your answer should be compact. 1.21. What is the ratio of the Aid flow (current US$) of El Salvador in 1997 to that in 1999?
Your answer should be very brief. 1.65. What is the ratio of the Aid flow (current US$) in Georgia in 1997 to that in 1999?
Your answer should be very brief. 1.6. What is the ratio of the Aid flow (current US$) in Chad in 1997 to that in 2000?
Ensure brevity in your answer.  1.95. What is the ratio of the Aid flow (current US$) in Colombia in 1997 to that in 2000?
Give a very brief answer. 1.57. What is the ratio of the Aid flow (current US$) of El Salvador in 1997 to that in 2000?
Ensure brevity in your answer.  6.44. What is the ratio of the Aid flow (current US$) in Georgia in 1997 to that in 2000?
Keep it short and to the point. 2.41. What is the ratio of the Aid flow (current US$) in Chad in 1997 to that in 2001?
Offer a very short reply. 1.22. What is the ratio of the Aid flow (current US$) in Colombia in 1997 to that in 2001?
Give a very brief answer. 1.71. What is the ratio of the Aid flow (current US$) in El Salvador in 1997 to that in 2001?
Your answer should be very brief. 6.02. What is the ratio of the Aid flow (current US$) of Georgia in 1997 to that in 2001?
Your response must be concise. 1.01. What is the ratio of the Aid flow (current US$) of Chad in 1997 to that in 2002?
Ensure brevity in your answer.  1.38. What is the ratio of the Aid flow (current US$) of Colombia in 1997 to that in 2002?
Give a very brief answer. 1.08. What is the ratio of the Aid flow (current US$) of El Salvador in 1997 to that in 2002?
Your answer should be compact. 2.14. What is the ratio of the Aid flow (current US$) in Georgia in 1997 to that in 2002?
Offer a very short reply. 1.01. What is the ratio of the Aid flow (current US$) in Chad in 1998 to that in 1999?
Give a very brief answer. 1.21. What is the ratio of the Aid flow (current US$) of Colombia in 1998 to that in 1999?
Offer a terse response. 1.02. What is the ratio of the Aid flow (current US$) of El Salvador in 1998 to that in 1999?
Provide a succinct answer. 1.88. What is the ratio of the Aid flow (current US$) in Georgia in 1998 to that in 1999?
Make the answer very short. 0.75. What is the ratio of the Aid flow (current US$) in Chad in 1998 to that in 2000?
Your response must be concise. 1.71. What is the ratio of the Aid flow (current US$) in Colombia in 1998 to that in 2000?
Offer a very short reply. 1.32. What is the ratio of the Aid flow (current US$) in El Salvador in 1998 to that in 2000?
Offer a terse response. 7.35. What is the ratio of the Aid flow (current US$) in Georgia in 1998 to that in 2000?
Your response must be concise. 1.14. What is the ratio of the Aid flow (current US$) of Chad in 1998 to that in 2001?
Your answer should be compact. 1.07. What is the ratio of the Aid flow (current US$) of Colombia in 1998 to that in 2001?
Your answer should be compact. 1.44. What is the ratio of the Aid flow (current US$) of El Salvador in 1998 to that in 2001?
Offer a very short reply. 6.87. What is the ratio of the Aid flow (current US$) in Georgia in 1998 to that in 2001?
Make the answer very short. 0.48. What is the ratio of the Aid flow (current US$) in Chad in 1998 to that in 2002?
Your answer should be very brief. 1.21. What is the ratio of the Aid flow (current US$) of El Salvador in 1998 to that in 2002?
Provide a succinct answer. 2.44. What is the ratio of the Aid flow (current US$) in Georgia in 1998 to that in 2002?
Provide a succinct answer. 0.47. What is the ratio of the Aid flow (current US$) of Chad in 1999 to that in 2000?
Ensure brevity in your answer.  1.41. What is the ratio of the Aid flow (current US$) in Colombia in 1999 to that in 2000?
Your answer should be compact. 1.3. What is the ratio of the Aid flow (current US$) of Georgia in 1999 to that in 2000?
Provide a succinct answer. 1.51. What is the ratio of the Aid flow (current US$) of Chad in 1999 to that in 2001?
Offer a very short reply. 0.88. What is the ratio of the Aid flow (current US$) of Colombia in 1999 to that in 2001?
Give a very brief answer. 1.41. What is the ratio of the Aid flow (current US$) of El Salvador in 1999 to that in 2001?
Make the answer very short. 3.64. What is the ratio of the Aid flow (current US$) in Georgia in 1999 to that in 2001?
Ensure brevity in your answer.  0.63. What is the ratio of the Aid flow (current US$) in Colombia in 1999 to that in 2002?
Offer a terse response. 0.89. What is the ratio of the Aid flow (current US$) of El Salvador in 1999 to that in 2002?
Keep it short and to the point. 1.3. What is the ratio of the Aid flow (current US$) of Georgia in 1999 to that in 2002?
Provide a succinct answer. 0.63. What is the ratio of the Aid flow (current US$) in Chad in 2000 to that in 2001?
Make the answer very short. 0.62. What is the ratio of the Aid flow (current US$) of Colombia in 2000 to that in 2001?
Provide a short and direct response. 1.09. What is the ratio of the Aid flow (current US$) of El Salvador in 2000 to that in 2001?
Offer a very short reply. 0.93. What is the ratio of the Aid flow (current US$) in Georgia in 2000 to that in 2001?
Your answer should be very brief. 0.42. What is the ratio of the Aid flow (current US$) in Chad in 2000 to that in 2002?
Your response must be concise. 0.71. What is the ratio of the Aid flow (current US$) of Colombia in 2000 to that in 2002?
Provide a short and direct response. 0.69. What is the ratio of the Aid flow (current US$) of El Salvador in 2000 to that in 2002?
Offer a terse response. 0.33. What is the ratio of the Aid flow (current US$) in Georgia in 2000 to that in 2002?
Keep it short and to the point. 0.42. What is the ratio of the Aid flow (current US$) in Chad in 2001 to that in 2002?
Your response must be concise. 1.14. What is the ratio of the Aid flow (current US$) of Colombia in 2001 to that in 2002?
Offer a terse response. 0.63. What is the ratio of the Aid flow (current US$) of El Salvador in 2001 to that in 2002?
Make the answer very short. 0.36. What is the difference between the highest and the second highest Aid flow (current US$) in Chad?
Make the answer very short. 2.53e+07. What is the difference between the highest and the second highest Aid flow (current US$) in Colombia?
Keep it short and to the point. 2.50e+06. What is the difference between the highest and the second highest Aid flow (current US$) in El Salvador?
Offer a terse response. 9.10e+05. What is the difference between the highest and the second highest Aid flow (current US$) in Georgia?
Ensure brevity in your answer.  6.20e+05. What is the difference between the highest and the lowest Aid flow (current US$) of Chad?
Offer a terse response. 4.88e+07. What is the difference between the highest and the lowest Aid flow (current US$) in Colombia?
Your answer should be compact. 8.29e+06. What is the difference between the highest and the lowest Aid flow (current US$) in El Salvador?
Your answer should be compact. 6.35e+06. What is the difference between the highest and the lowest Aid flow (current US$) of Georgia?
Offer a very short reply. 1.76e+06. 